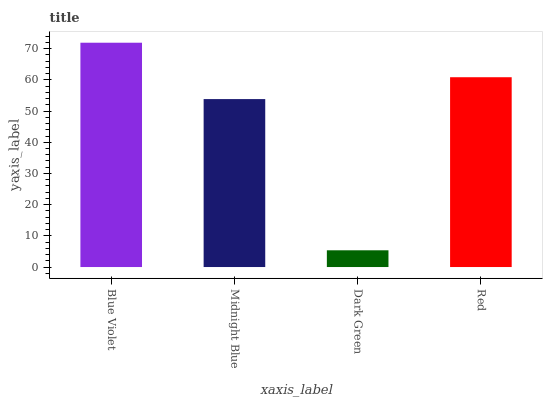Is Dark Green the minimum?
Answer yes or no. Yes. Is Blue Violet the maximum?
Answer yes or no. Yes. Is Midnight Blue the minimum?
Answer yes or no. No. Is Midnight Blue the maximum?
Answer yes or no. No. Is Blue Violet greater than Midnight Blue?
Answer yes or no. Yes. Is Midnight Blue less than Blue Violet?
Answer yes or no. Yes. Is Midnight Blue greater than Blue Violet?
Answer yes or no. No. Is Blue Violet less than Midnight Blue?
Answer yes or no. No. Is Red the high median?
Answer yes or no. Yes. Is Midnight Blue the low median?
Answer yes or no. Yes. Is Dark Green the high median?
Answer yes or no. No. Is Red the low median?
Answer yes or no. No. 